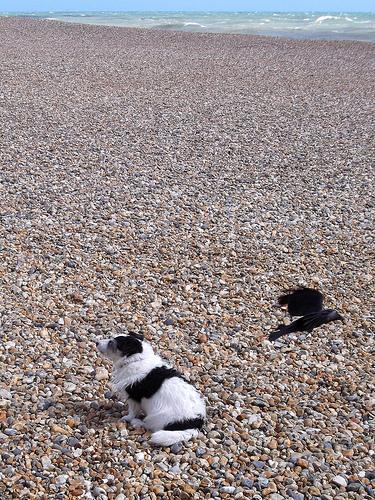How many birds are in the pic?
Give a very brief answer. 1. 